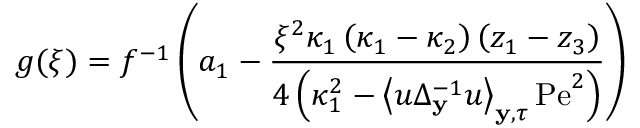<formula> <loc_0><loc_0><loc_500><loc_500>g ( \xi ) = f ^ { - 1 } \left ( a _ { 1 } - \frac { \xi ^ { 2 } \kappa _ { 1 } \left ( \kappa _ { 1 } - \kappa _ { 2 } \right ) \left ( z _ { 1 } - z _ { 3 } \right ) } { 4 \left ( \kappa _ { 1 } ^ { 2 } - \left \langle u \Delta _ { y } ^ { - 1 } u \right \rangle _ { y , \tau } P e ^ { 2 } \right ) } \right )</formula> 